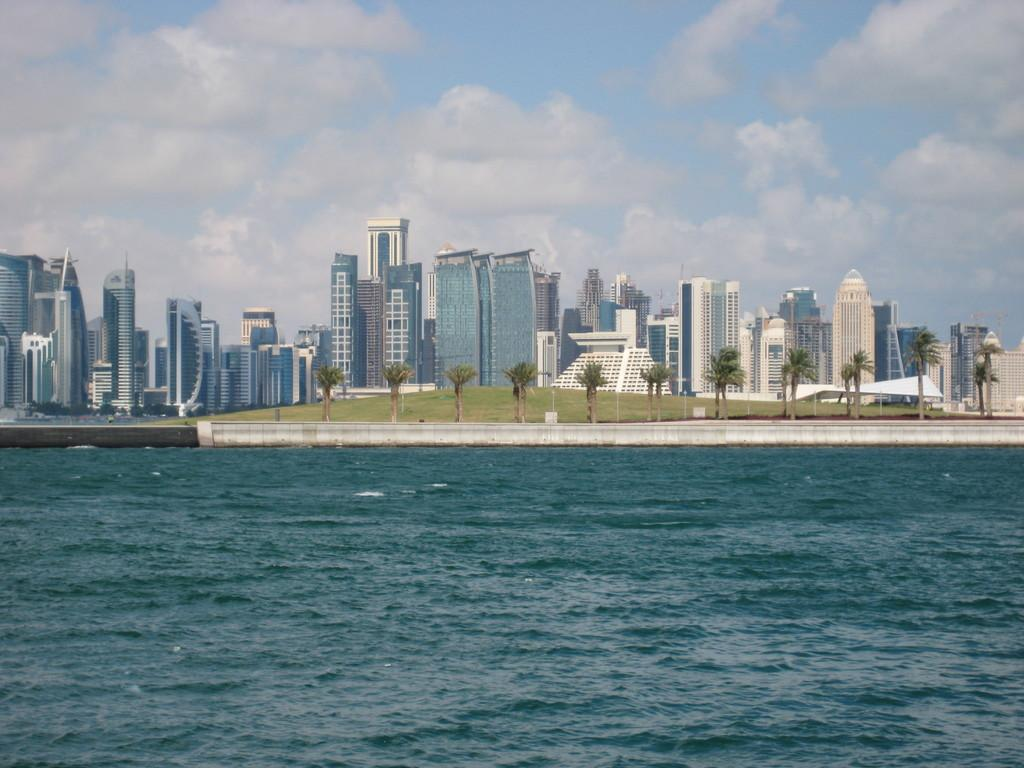What is one of the natural elements present in the image? There is water in the image. What type of vegetation can be seen in the image? There are trees and grass in the image. What type of man-made structures are visible in the image? There are buildings in the image. What can be seen in the background of the image? The sky is visible in the background of the image, and there are clouds in the sky. What type of feather can be seen falling from the sky in the image? There is no feather falling from the sky in the image. What disease is affecting the trees in the image? There is no indication of any disease affecting the trees in the image. 